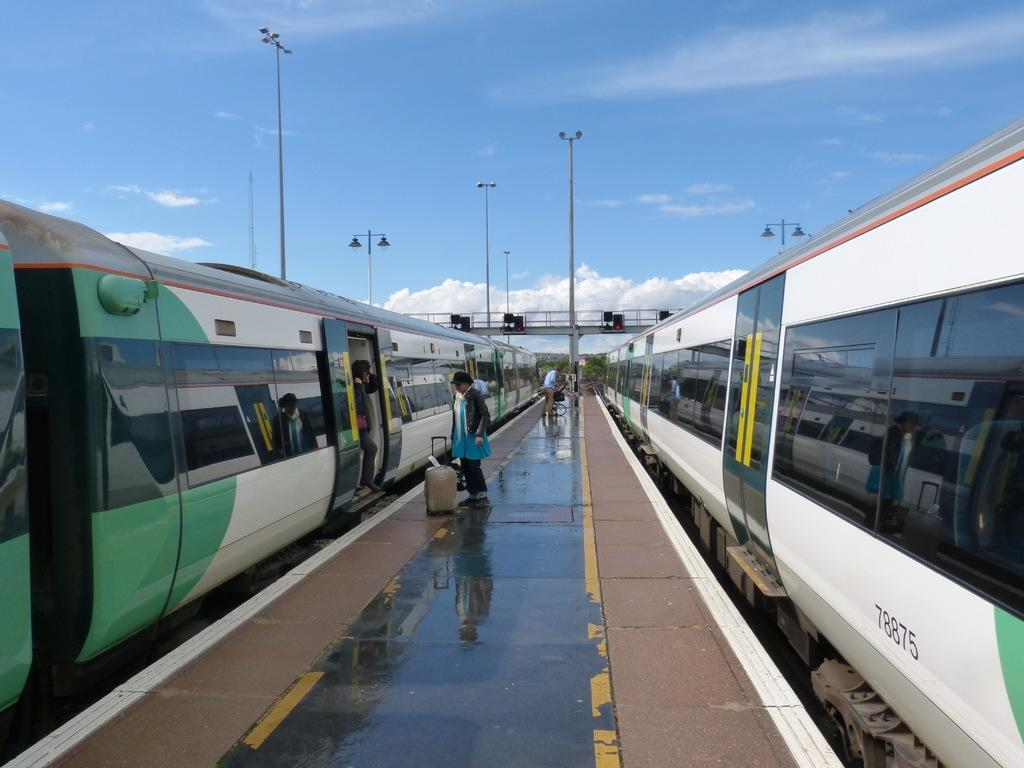What can be seen on the footpath in the image? There are people standing on the footpath in the image. What is located near the footpath? There are trains on the railway tracks on both sides in the image. How is the distribution of boats managed at the dock in the image? There is no dock present in the image, so the distribution of boats cannot be determined. What is the most efficient way for people to travel in the image? The image does not provide information about the most efficient way for people to travel, as it only shows people standing on a footpath and trains on railway tracks. 